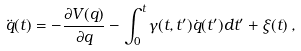<formula> <loc_0><loc_0><loc_500><loc_500>\ddot { q } ( t ) = - \frac { \partial V ( q ) } { \partial q } - \int _ { 0 } ^ { t } { \gamma ( t , t ^ { \prime } ) \dot { q } ( t ^ { \prime } ) d t ^ { \prime } } + \xi ( t ) \, ,</formula> 